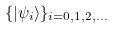<formula> <loc_0><loc_0><loc_500><loc_500>\{ | \psi _ { i } \rangle \} _ { i = 0 , 1 , 2 , \dots }</formula> 